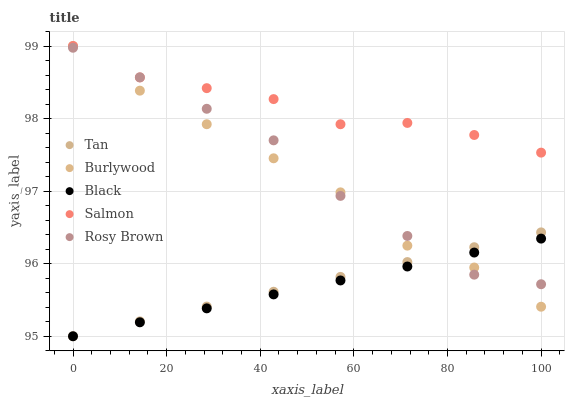Does Black have the minimum area under the curve?
Answer yes or no. Yes. Does Salmon have the maximum area under the curve?
Answer yes or no. Yes. Does Tan have the minimum area under the curve?
Answer yes or no. No. Does Tan have the maximum area under the curve?
Answer yes or no. No. Is Black the smoothest?
Answer yes or no. Yes. Is Salmon the roughest?
Answer yes or no. Yes. Is Tan the smoothest?
Answer yes or no. No. Is Tan the roughest?
Answer yes or no. No. Does Tan have the lowest value?
Answer yes or no. Yes. Does Salmon have the lowest value?
Answer yes or no. No. Does Salmon have the highest value?
Answer yes or no. Yes. Does Tan have the highest value?
Answer yes or no. No. Is Black less than Salmon?
Answer yes or no. Yes. Is Salmon greater than Black?
Answer yes or no. Yes. Does Tan intersect Rosy Brown?
Answer yes or no. Yes. Is Tan less than Rosy Brown?
Answer yes or no. No. Is Tan greater than Rosy Brown?
Answer yes or no. No. Does Black intersect Salmon?
Answer yes or no. No. 